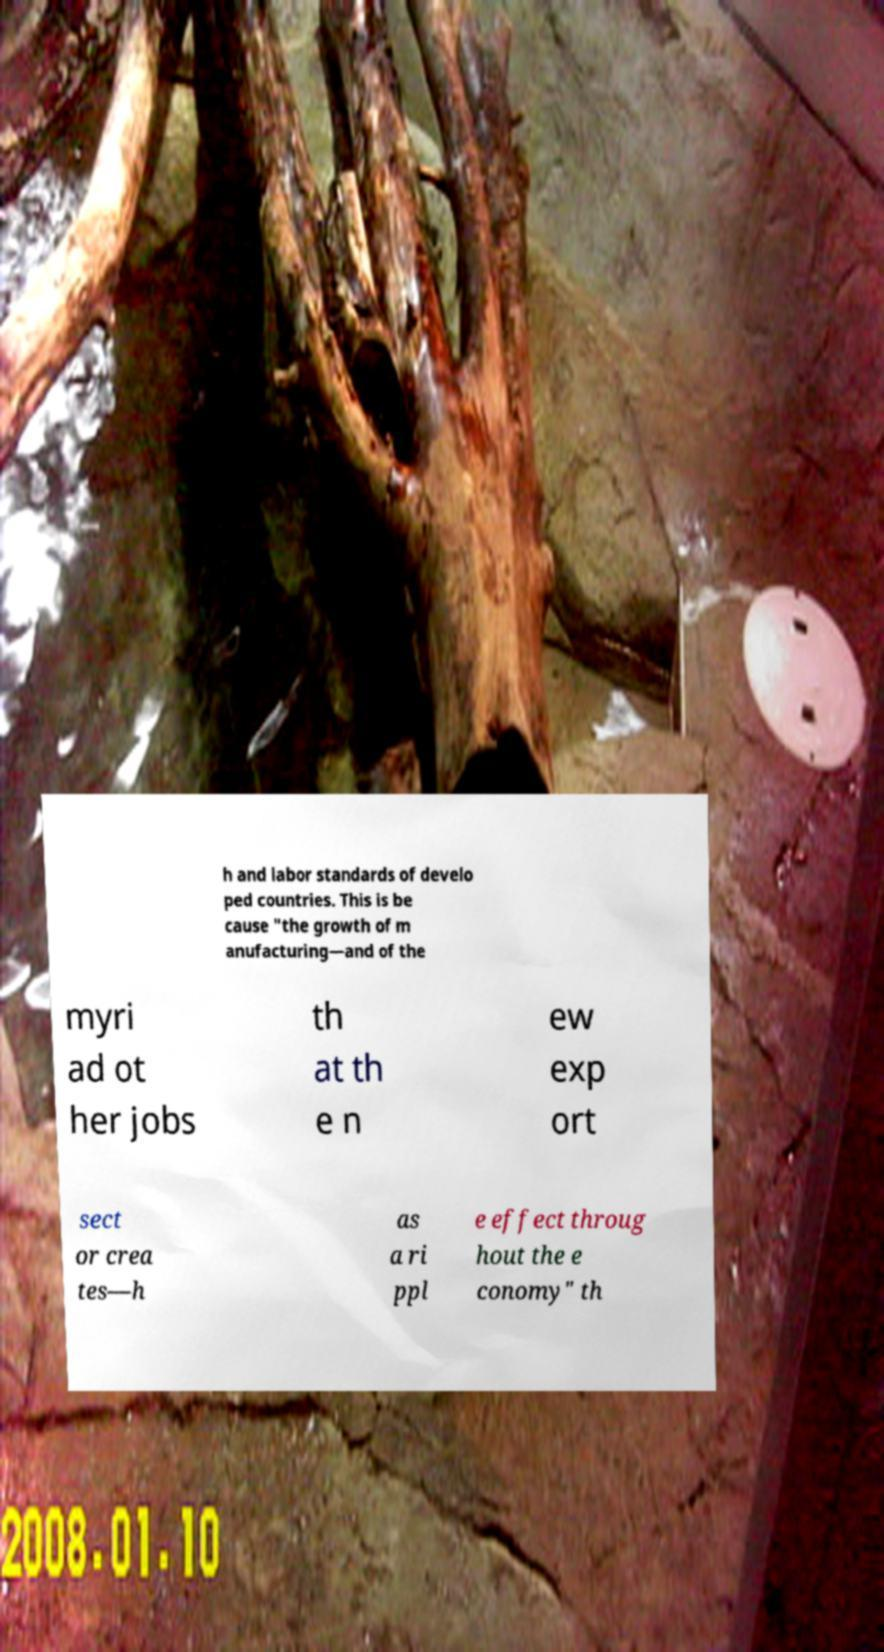Could you extract and type out the text from this image? h and labor standards of develo ped countries. This is be cause "the growth of m anufacturing—and of the myri ad ot her jobs th at th e n ew exp ort sect or crea tes—h as a ri ppl e effect throug hout the e conomy" th 